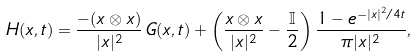<formula> <loc_0><loc_0><loc_500><loc_500>H ( x , t ) = \frac { - ( x \otimes x ) } { | x | ^ { 2 } } \, G ( x , t ) + \left ( \frac { x \otimes x } { | x | ^ { 2 } } - \frac { \mathbb { I } } { 2 } \right ) \frac { 1 - e ^ { - | x | ^ { 2 } / 4 t } } { \pi | x | ^ { 2 } } ,</formula> 